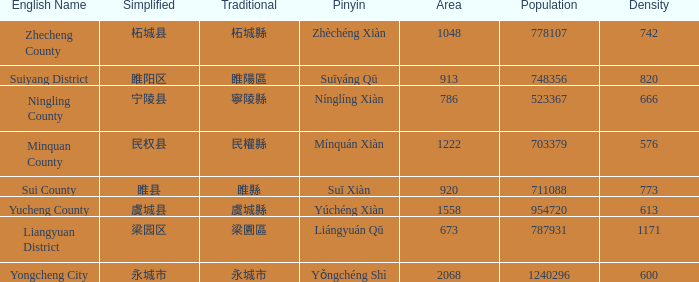What is the traditional form for 宁陵县? 寧陵縣. 